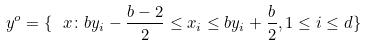<formula> <loc_0><loc_0><loc_500><loc_500>\ y ^ { o } = \{ \ x \colon b y _ { i } - \frac { b - 2 } { 2 } \leq x _ { i } \leq b y _ { i } + \frac { b } { 2 } , 1 \leq i \leq d \}</formula> 